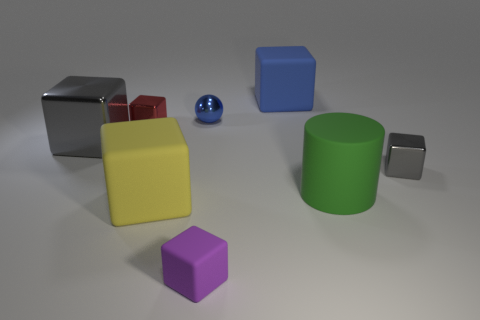Add 2 tiny rubber cubes. How many objects exist? 10 Subtract all big rubber cubes. How many cubes are left? 4 Subtract all blue blocks. How many blocks are left? 5 Subtract 1 balls. How many balls are left? 0 Subtract 0 brown balls. How many objects are left? 8 Subtract all balls. How many objects are left? 7 Subtract all gray spheres. Subtract all cyan cylinders. How many spheres are left? 1 Subtract all gray cubes. How many brown spheres are left? 0 Subtract all small blue metallic objects. Subtract all tiny blue balls. How many objects are left? 6 Add 4 gray things. How many gray things are left? 6 